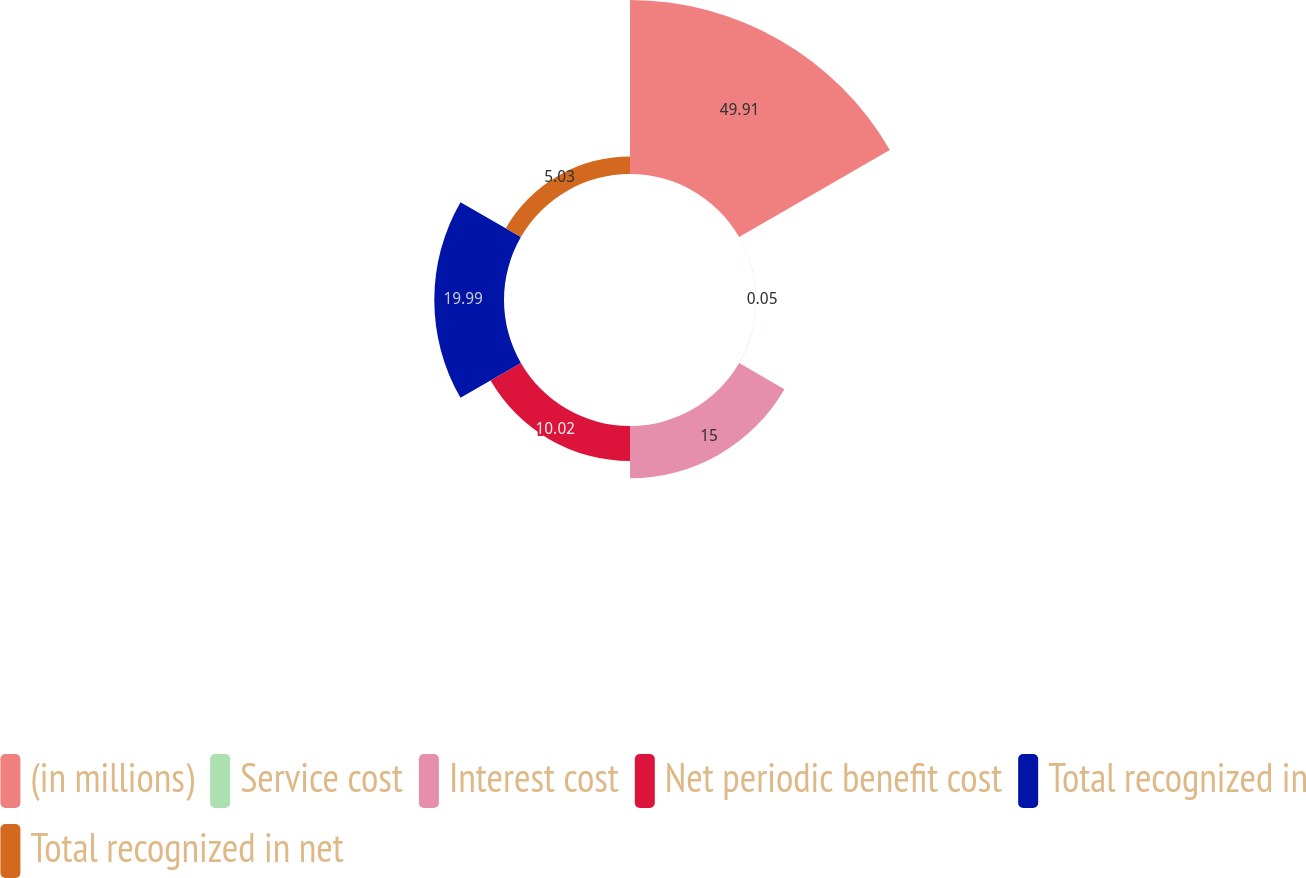Convert chart to OTSL. <chart><loc_0><loc_0><loc_500><loc_500><pie_chart><fcel>(in millions)<fcel>Service cost<fcel>Interest cost<fcel>Net periodic benefit cost<fcel>Total recognized in<fcel>Total recognized in net<nl><fcel>49.9%<fcel>0.05%<fcel>15.0%<fcel>10.02%<fcel>19.99%<fcel>5.03%<nl></chart> 